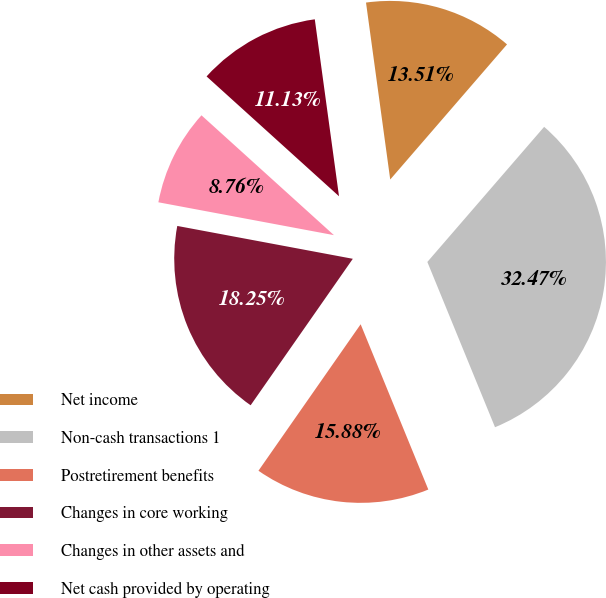<chart> <loc_0><loc_0><loc_500><loc_500><pie_chart><fcel>Net income<fcel>Non-cash transactions 1<fcel>Postretirement benefits<fcel>Changes in core working<fcel>Changes in other assets and<fcel>Net cash provided by operating<nl><fcel>13.51%<fcel>32.47%<fcel>15.88%<fcel>18.25%<fcel>8.76%<fcel>11.13%<nl></chart> 